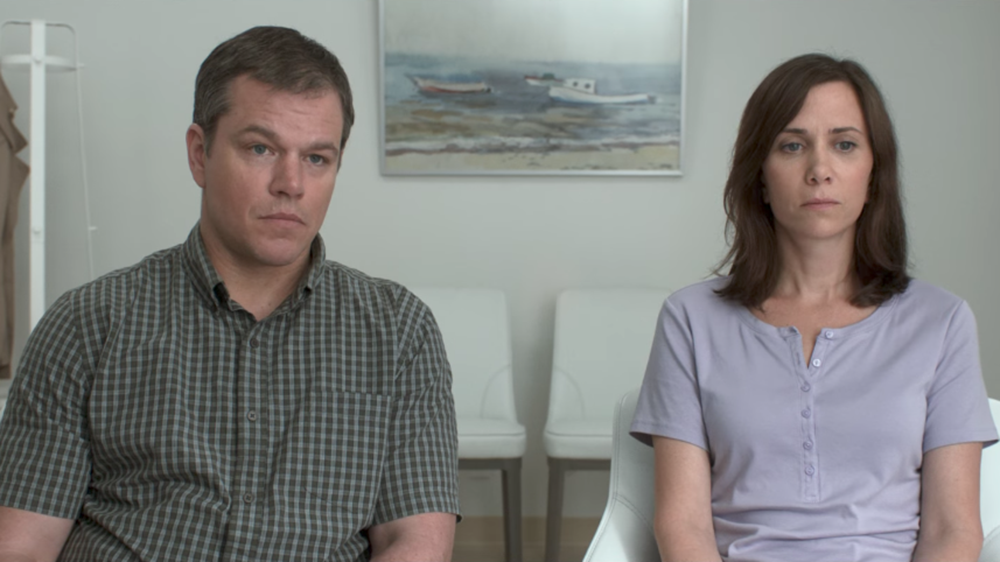Why might these two individuals be seated in this room? The two individuals may be seated in this room for a consultation or an important discussion. Given their thoughtful and serious expressions, they could be waiting to speak with a professional, such as a therapist, lawyer, or counselor. The room’s minimalist design and the painting's serene imagery suggest that this place is intended to provide a calm and focused atmosphere, helping them prepare for the serious topic at hand. Can you weave a short narrative around this setting? In a quiet clinic, Sarah and John wait silently in the consultation room, where the only adornment is a serene painting of a boat. They have spent weeks preparing for this moment, knowing that today they will hear the results that will determine the next steps in their journey. As time ticks slowly, their minds race through emotions and scenarios, holding onto a shared hope that they can face whatever comes next, together. 